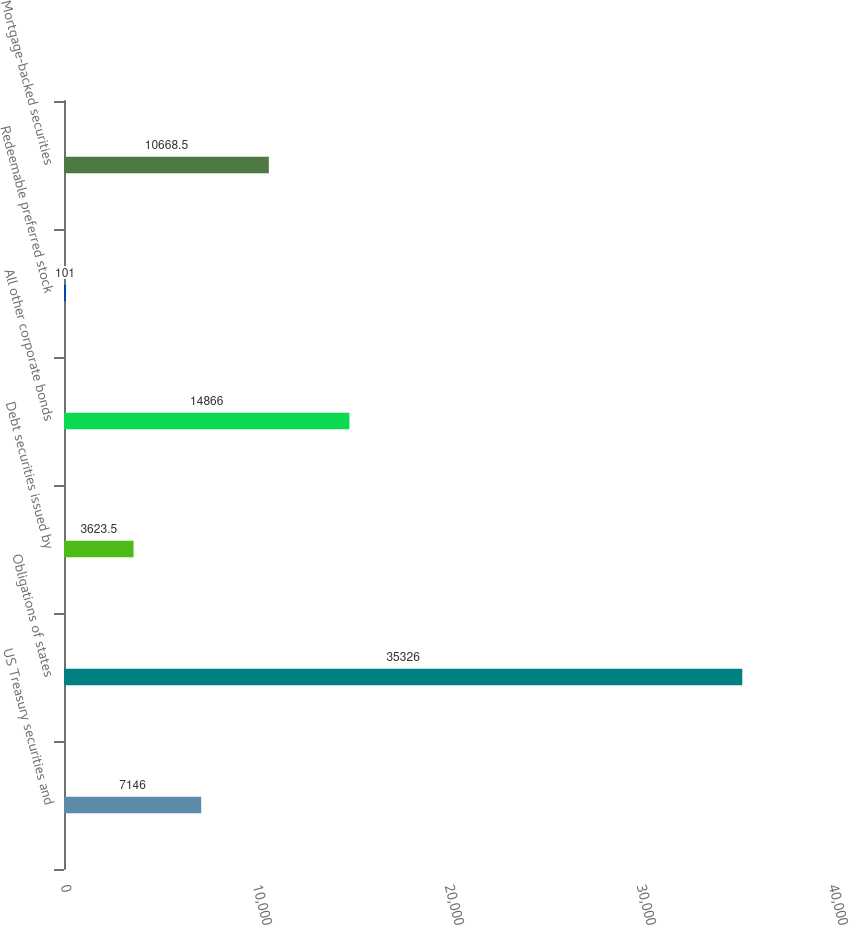<chart> <loc_0><loc_0><loc_500><loc_500><bar_chart><fcel>US Treasury securities and<fcel>Obligations of states<fcel>Debt securities issued by<fcel>All other corporate bonds<fcel>Redeemable preferred stock<fcel>Mortgage-backed securities<nl><fcel>7146<fcel>35326<fcel>3623.5<fcel>14866<fcel>101<fcel>10668.5<nl></chart> 